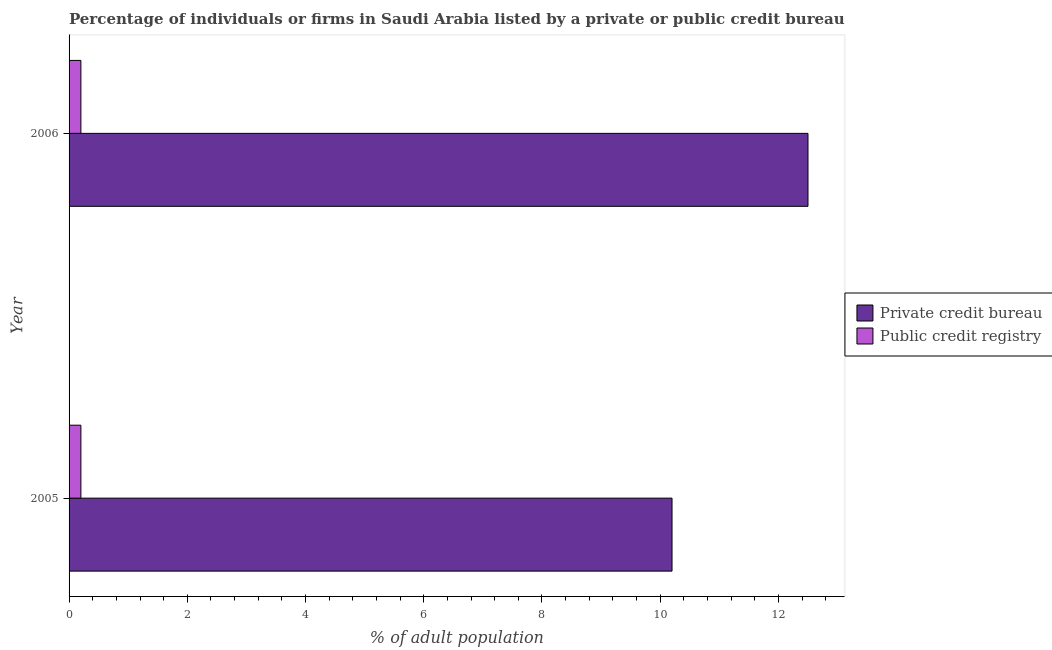How many groups of bars are there?
Your answer should be very brief. 2. Across all years, what is the maximum percentage of firms listed by private credit bureau?
Provide a short and direct response. 12.5. What is the total percentage of firms listed by public credit bureau in the graph?
Offer a very short reply. 0.4. What is the difference between the percentage of firms listed by private credit bureau in 2005 and that in 2006?
Offer a very short reply. -2.3. What is the average percentage of firms listed by public credit bureau per year?
Make the answer very short. 0.2. In how many years, is the percentage of firms listed by public credit bureau greater than 4.4 %?
Give a very brief answer. 0. Is the percentage of firms listed by private credit bureau in 2005 less than that in 2006?
Your response must be concise. Yes. What does the 2nd bar from the top in 2006 represents?
Offer a terse response. Private credit bureau. What does the 2nd bar from the bottom in 2006 represents?
Your answer should be compact. Public credit registry. Are all the bars in the graph horizontal?
Your response must be concise. Yes. How many years are there in the graph?
Your answer should be compact. 2. Does the graph contain grids?
Offer a terse response. No. Where does the legend appear in the graph?
Keep it short and to the point. Center right. What is the title of the graph?
Ensure brevity in your answer.  Percentage of individuals or firms in Saudi Arabia listed by a private or public credit bureau. Does "Food and tobacco" appear as one of the legend labels in the graph?
Offer a terse response. No. What is the label or title of the X-axis?
Provide a short and direct response. % of adult population. What is the % of adult population of Private credit bureau in 2005?
Provide a succinct answer. 10.2. Across all years, what is the maximum % of adult population in Public credit registry?
Ensure brevity in your answer.  0.2. Across all years, what is the minimum % of adult population of Public credit registry?
Offer a terse response. 0.2. What is the total % of adult population in Private credit bureau in the graph?
Provide a short and direct response. 22.7. What is the total % of adult population of Public credit registry in the graph?
Ensure brevity in your answer.  0.4. What is the average % of adult population in Private credit bureau per year?
Provide a short and direct response. 11.35. In the year 2005, what is the difference between the % of adult population in Private credit bureau and % of adult population in Public credit registry?
Ensure brevity in your answer.  10. In the year 2006, what is the difference between the % of adult population of Private credit bureau and % of adult population of Public credit registry?
Offer a very short reply. 12.3. What is the ratio of the % of adult population in Private credit bureau in 2005 to that in 2006?
Provide a short and direct response. 0.82. What is the ratio of the % of adult population of Public credit registry in 2005 to that in 2006?
Your response must be concise. 1. What is the difference between the highest and the second highest % of adult population in Private credit bureau?
Ensure brevity in your answer.  2.3. What is the difference between the highest and the lowest % of adult population in Private credit bureau?
Make the answer very short. 2.3. What is the difference between the highest and the lowest % of adult population of Public credit registry?
Your answer should be very brief. 0. 